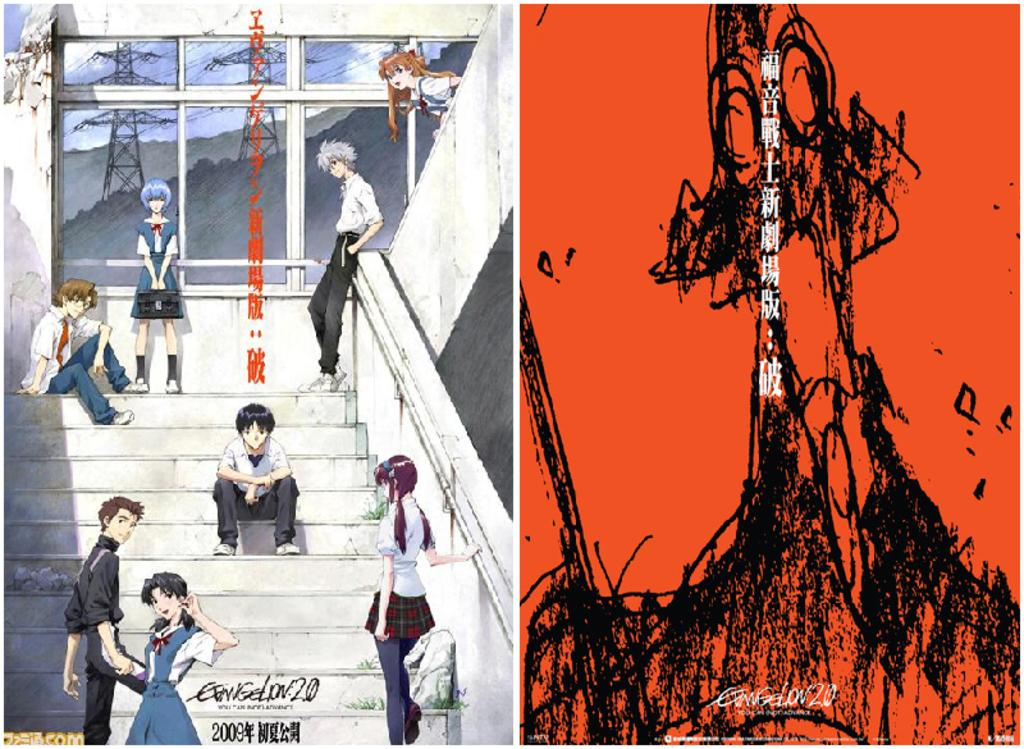<image>
Provide a brief description of the given image. An anime illustrated poster says 2009 at the bottom. 